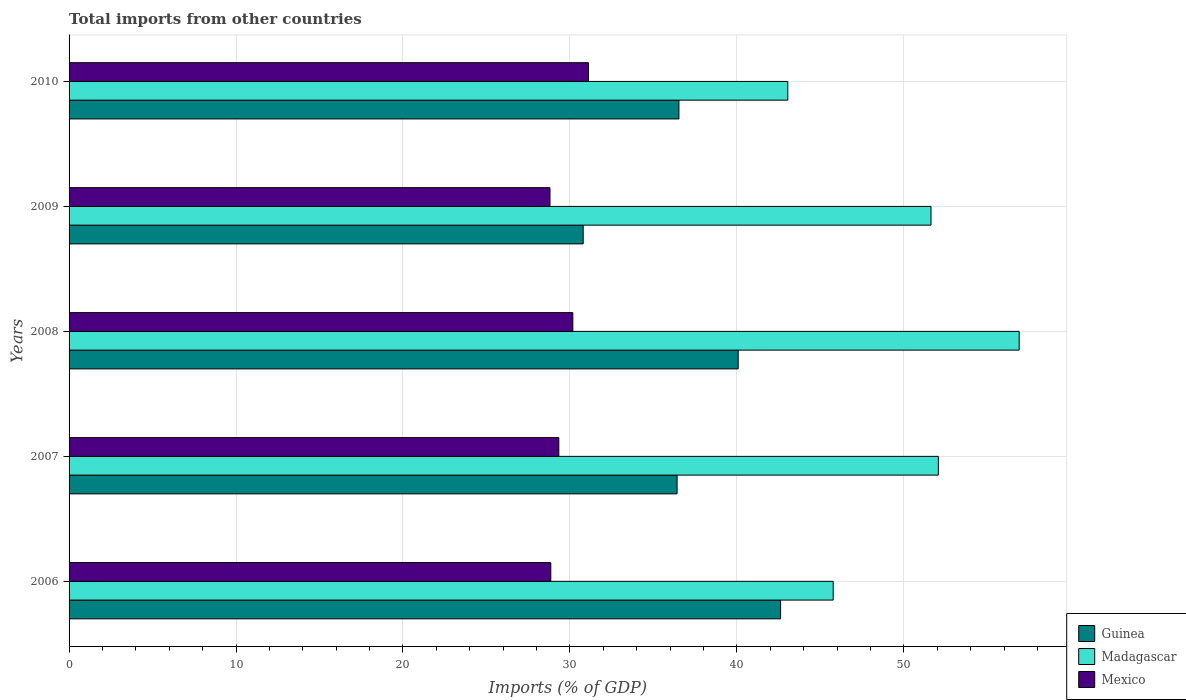How many groups of bars are there?
Ensure brevity in your answer.  5. How many bars are there on the 4th tick from the top?
Offer a terse response. 3. How many bars are there on the 4th tick from the bottom?
Provide a succinct answer. 3. What is the label of the 5th group of bars from the top?
Your answer should be very brief. 2006. In how many cases, is the number of bars for a given year not equal to the number of legend labels?
Ensure brevity in your answer.  0. What is the total imports in Guinea in 2010?
Give a very brief answer. 36.53. Across all years, what is the maximum total imports in Madagascar?
Give a very brief answer. 56.91. Across all years, what is the minimum total imports in Guinea?
Keep it short and to the point. 30.79. In which year was the total imports in Guinea maximum?
Your answer should be compact. 2006. In which year was the total imports in Madagascar minimum?
Ensure brevity in your answer.  2010. What is the total total imports in Guinea in the graph?
Give a very brief answer. 186.43. What is the difference between the total imports in Mexico in 2006 and that in 2010?
Make the answer very short. -2.26. What is the difference between the total imports in Mexico in 2006 and the total imports in Madagascar in 2009?
Offer a very short reply. -22.77. What is the average total imports in Guinea per year?
Your response must be concise. 37.29. In the year 2010, what is the difference between the total imports in Guinea and total imports in Madagascar?
Ensure brevity in your answer.  -6.52. In how many years, is the total imports in Madagascar greater than 50 %?
Offer a very short reply. 3. What is the ratio of the total imports in Guinea in 2008 to that in 2010?
Your response must be concise. 1.1. What is the difference between the highest and the second highest total imports in Guinea?
Your answer should be very brief. 2.54. What is the difference between the highest and the lowest total imports in Guinea?
Provide a succinct answer. 11.82. In how many years, is the total imports in Mexico greater than the average total imports in Mexico taken over all years?
Offer a terse response. 2. What does the 3rd bar from the top in 2006 represents?
Provide a short and direct response. Guinea. What does the 1st bar from the bottom in 2007 represents?
Provide a succinct answer. Guinea. Is it the case that in every year, the sum of the total imports in Mexico and total imports in Madagascar is greater than the total imports in Guinea?
Keep it short and to the point. Yes. How many bars are there?
Give a very brief answer. 15. How many years are there in the graph?
Offer a terse response. 5. Are the values on the major ticks of X-axis written in scientific E-notation?
Offer a terse response. No. Where does the legend appear in the graph?
Keep it short and to the point. Bottom right. What is the title of the graph?
Your response must be concise. Total imports from other countries. What is the label or title of the X-axis?
Provide a succinct answer. Imports (% of GDP). What is the label or title of the Y-axis?
Provide a succinct answer. Years. What is the Imports (% of GDP) in Guinea in 2006?
Keep it short and to the point. 42.62. What is the Imports (% of GDP) of Madagascar in 2006?
Make the answer very short. 45.77. What is the Imports (% of GDP) of Mexico in 2006?
Make the answer very short. 28.85. What is the Imports (% of GDP) of Guinea in 2007?
Offer a very short reply. 36.42. What is the Imports (% of GDP) of Madagascar in 2007?
Keep it short and to the point. 52.07. What is the Imports (% of GDP) in Mexico in 2007?
Provide a short and direct response. 29.33. What is the Imports (% of GDP) of Guinea in 2008?
Keep it short and to the point. 40.08. What is the Imports (% of GDP) in Madagascar in 2008?
Offer a terse response. 56.91. What is the Imports (% of GDP) in Mexico in 2008?
Provide a succinct answer. 30.17. What is the Imports (% of GDP) of Guinea in 2009?
Ensure brevity in your answer.  30.79. What is the Imports (% of GDP) of Madagascar in 2009?
Keep it short and to the point. 51.63. What is the Imports (% of GDP) of Mexico in 2009?
Your response must be concise. 28.81. What is the Imports (% of GDP) of Guinea in 2010?
Keep it short and to the point. 36.53. What is the Imports (% of GDP) of Madagascar in 2010?
Give a very brief answer. 43.05. What is the Imports (% of GDP) in Mexico in 2010?
Provide a short and direct response. 31.11. Across all years, what is the maximum Imports (% of GDP) of Guinea?
Your answer should be compact. 42.62. Across all years, what is the maximum Imports (% of GDP) in Madagascar?
Ensure brevity in your answer.  56.91. Across all years, what is the maximum Imports (% of GDP) of Mexico?
Provide a succinct answer. 31.11. Across all years, what is the minimum Imports (% of GDP) in Guinea?
Provide a succinct answer. 30.79. Across all years, what is the minimum Imports (% of GDP) in Madagascar?
Provide a succinct answer. 43.05. Across all years, what is the minimum Imports (% of GDP) of Mexico?
Provide a succinct answer. 28.81. What is the total Imports (% of GDP) in Guinea in the graph?
Ensure brevity in your answer.  186.43. What is the total Imports (% of GDP) in Madagascar in the graph?
Your answer should be very brief. 249.42. What is the total Imports (% of GDP) in Mexico in the graph?
Give a very brief answer. 148.28. What is the difference between the Imports (% of GDP) of Guinea in 2006 and that in 2007?
Keep it short and to the point. 6.2. What is the difference between the Imports (% of GDP) of Madagascar in 2006 and that in 2007?
Your answer should be compact. -6.3. What is the difference between the Imports (% of GDP) of Mexico in 2006 and that in 2007?
Your response must be concise. -0.48. What is the difference between the Imports (% of GDP) in Guinea in 2006 and that in 2008?
Your answer should be very brief. 2.54. What is the difference between the Imports (% of GDP) of Madagascar in 2006 and that in 2008?
Offer a terse response. -11.14. What is the difference between the Imports (% of GDP) in Mexico in 2006 and that in 2008?
Ensure brevity in your answer.  -1.32. What is the difference between the Imports (% of GDP) of Guinea in 2006 and that in 2009?
Ensure brevity in your answer.  11.82. What is the difference between the Imports (% of GDP) in Madagascar in 2006 and that in 2009?
Provide a short and direct response. -5.86. What is the difference between the Imports (% of GDP) in Mexico in 2006 and that in 2009?
Your answer should be compact. 0.05. What is the difference between the Imports (% of GDP) in Guinea in 2006 and that in 2010?
Offer a very short reply. 6.09. What is the difference between the Imports (% of GDP) in Madagascar in 2006 and that in 2010?
Your answer should be compact. 2.72. What is the difference between the Imports (% of GDP) in Mexico in 2006 and that in 2010?
Offer a very short reply. -2.26. What is the difference between the Imports (% of GDP) of Guinea in 2007 and that in 2008?
Offer a very short reply. -3.66. What is the difference between the Imports (% of GDP) in Madagascar in 2007 and that in 2008?
Ensure brevity in your answer.  -4.84. What is the difference between the Imports (% of GDP) in Mexico in 2007 and that in 2008?
Offer a terse response. -0.84. What is the difference between the Imports (% of GDP) in Guinea in 2007 and that in 2009?
Keep it short and to the point. 5.63. What is the difference between the Imports (% of GDP) in Madagascar in 2007 and that in 2009?
Give a very brief answer. 0.44. What is the difference between the Imports (% of GDP) in Mexico in 2007 and that in 2009?
Your answer should be very brief. 0.53. What is the difference between the Imports (% of GDP) of Guinea in 2007 and that in 2010?
Offer a very short reply. -0.11. What is the difference between the Imports (% of GDP) in Madagascar in 2007 and that in 2010?
Give a very brief answer. 9.02. What is the difference between the Imports (% of GDP) in Mexico in 2007 and that in 2010?
Your answer should be very brief. -1.78. What is the difference between the Imports (% of GDP) in Guinea in 2008 and that in 2009?
Provide a succinct answer. 9.28. What is the difference between the Imports (% of GDP) of Madagascar in 2008 and that in 2009?
Provide a succinct answer. 5.28. What is the difference between the Imports (% of GDP) in Mexico in 2008 and that in 2009?
Offer a terse response. 1.37. What is the difference between the Imports (% of GDP) in Guinea in 2008 and that in 2010?
Keep it short and to the point. 3.55. What is the difference between the Imports (% of GDP) in Madagascar in 2008 and that in 2010?
Ensure brevity in your answer.  13.86. What is the difference between the Imports (% of GDP) in Mexico in 2008 and that in 2010?
Keep it short and to the point. -0.94. What is the difference between the Imports (% of GDP) in Guinea in 2009 and that in 2010?
Your response must be concise. -5.73. What is the difference between the Imports (% of GDP) in Madagascar in 2009 and that in 2010?
Your response must be concise. 8.58. What is the difference between the Imports (% of GDP) in Mexico in 2009 and that in 2010?
Offer a terse response. -2.31. What is the difference between the Imports (% of GDP) in Guinea in 2006 and the Imports (% of GDP) in Madagascar in 2007?
Offer a very short reply. -9.45. What is the difference between the Imports (% of GDP) in Guinea in 2006 and the Imports (% of GDP) in Mexico in 2007?
Your answer should be very brief. 13.28. What is the difference between the Imports (% of GDP) in Madagascar in 2006 and the Imports (% of GDP) in Mexico in 2007?
Your answer should be very brief. 16.43. What is the difference between the Imports (% of GDP) in Guinea in 2006 and the Imports (% of GDP) in Madagascar in 2008?
Your response must be concise. -14.29. What is the difference between the Imports (% of GDP) in Guinea in 2006 and the Imports (% of GDP) in Mexico in 2008?
Offer a terse response. 12.44. What is the difference between the Imports (% of GDP) in Madagascar in 2006 and the Imports (% of GDP) in Mexico in 2008?
Provide a short and direct response. 15.6. What is the difference between the Imports (% of GDP) in Guinea in 2006 and the Imports (% of GDP) in Madagascar in 2009?
Give a very brief answer. -9.01. What is the difference between the Imports (% of GDP) of Guinea in 2006 and the Imports (% of GDP) of Mexico in 2009?
Provide a succinct answer. 13.81. What is the difference between the Imports (% of GDP) of Madagascar in 2006 and the Imports (% of GDP) of Mexico in 2009?
Keep it short and to the point. 16.96. What is the difference between the Imports (% of GDP) in Guinea in 2006 and the Imports (% of GDP) in Madagascar in 2010?
Your answer should be compact. -0.43. What is the difference between the Imports (% of GDP) of Guinea in 2006 and the Imports (% of GDP) of Mexico in 2010?
Give a very brief answer. 11.51. What is the difference between the Imports (% of GDP) of Madagascar in 2006 and the Imports (% of GDP) of Mexico in 2010?
Provide a succinct answer. 14.66. What is the difference between the Imports (% of GDP) in Guinea in 2007 and the Imports (% of GDP) in Madagascar in 2008?
Keep it short and to the point. -20.49. What is the difference between the Imports (% of GDP) in Guinea in 2007 and the Imports (% of GDP) in Mexico in 2008?
Your answer should be compact. 6.25. What is the difference between the Imports (% of GDP) of Madagascar in 2007 and the Imports (% of GDP) of Mexico in 2008?
Your answer should be very brief. 21.89. What is the difference between the Imports (% of GDP) of Guinea in 2007 and the Imports (% of GDP) of Madagascar in 2009?
Offer a terse response. -15.21. What is the difference between the Imports (% of GDP) of Guinea in 2007 and the Imports (% of GDP) of Mexico in 2009?
Keep it short and to the point. 7.61. What is the difference between the Imports (% of GDP) of Madagascar in 2007 and the Imports (% of GDP) of Mexico in 2009?
Your answer should be compact. 23.26. What is the difference between the Imports (% of GDP) of Guinea in 2007 and the Imports (% of GDP) of Madagascar in 2010?
Give a very brief answer. -6.63. What is the difference between the Imports (% of GDP) of Guinea in 2007 and the Imports (% of GDP) of Mexico in 2010?
Your answer should be compact. 5.31. What is the difference between the Imports (% of GDP) in Madagascar in 2007 and the Imports (% of GDP) in Mexico in 2010?
Make the answer very short. 20.96. What is the difference between the Imports (% of GDP) in Guinea in 2008 and the Imports (% of GDP) in Madagascar in 2009?
Give a very brief answer. -11.55. What is the difference between the Imports (% of GDP) of Guinea in 2008 and the Imports (% of GDP) of Mexico in 2009?
Provide a succinct answer. 11.27. What is the difference between the Imports (% of GDP) of Madagascar in 2008 and the Imports (% of GDP) of Mexico in 2009?
Your answer should be very brief. 28.1. What is the difference between the Imports (% of GDP) of Guinea in 2008 and the Imports (% of GDP) of Madagascar in 2010?
Provide a short and direct response. -2.97. What is the difference between the Imports (% of GDP) of Guinea in 2008 and the Imports (% of GDP) of Mexico in 2010?
Keep it short and to the point. 8.97. What is the difference between the Imports (% of GDP) of Madagascar in 2008 and the Imports (% of GDP) of Mexico in 2010?
Ensure brevity in your answer.  25.8. What is the difference between the Imports (% of GDP) in Guinea in 2009 and the Imports (% of GDP) in Madagascar in 2010?
Offer a terse response. -12.26. What is the difference between the Imports (% of GDP) in Guinea in 2009 and the Imports (% of GDP) in Mexico in 2010?
Provide a succinct answer. -0.32. What is the difference between the Imports (% of GDP) in Madagascar in 2009 and the Imports (% of GDP) in Mexico in 2010?
Your response must be concise. 20.52. What is the average Imports (% of GDP) of Guinea per year?
Provide a short and direct response. 37.29. What is the average Imports (% of GDP) in Madagascar per year?
Give a very brief answer. 49.88. What is the average Imports (% of GDP) in Mexico per year?
Your answer should be very brief. 29.66. In the year 2006, what is the difference between the Imports (% of GDP) of Guinea and Imports (% of GDP) of Madagascar?
Ensure brevity in your answer.  -3.15. In the year 2006, what is the difference between the Imports (% of GDP) in Guinea and Imports (% of GDP) in Mexico?
Offer a very short reply. 13.76. In the year 2006, what is the difference between the Imports (% of GDP) of Madagascar and Imports (% of GDP) of Mexico?
Offer a terse response. 16.91. In the year 2007, what is the difference between the Imports (% of GDP) in Guinea and Imports (% of GDP) in Madagascar?
Provide a succinct answer. -15.65. In the year 2007, what is the difference between the Imports (% of GDP) of Guinea and Imports (% of GDP) of Mexico?
Your answer should be compact. 7.08. In the year 2007, what is the difference between the Imports (% of GDP) in Madagascar and Imports (% of GDP) in Mexico?
Offer a terse response. 22.73. In the year 2008, what is the difference between the Imports (% of GDP) of Guinea and Imports (% of GDP) of Madagascar?
Give a very brief answer. -16.83. In the year 2008, what is the difference between the Imports (% of GDP) in Guinea and Imports (% of GDP) in Mexico?
Offer a terse response. 9.9. In the year 2008, what is the difference between the Imports (% of GDP) of Madagascar and Imports (% of GDP) of Mexico?
Your answer should be compact. 26.74. In the year 2009, what is the difference between the Imports (% of GDP) of Guinea and Imports (% of GDP) of Madagascar?
Provide a succinct answer. -20.83. In the year 2009, what is the difference between the Imports (% of GDP) in Guinea and Imports (% of GDP) in Mexico?
Offer a terse response. 1.99. In the year 2009, what is the difference between the Imports (% of GDP) of Madagascar and Imports (% of GDP) of Mexico?
Offer a very short reply. 22.82. In the year 2010, what is the difference between the Imports (% of GDP) in Guinea and Imports (% of GDP) in Madagascar?
Your response must be concise. -6.52. In the year 2010, what is the difference between the Imports (% of GDP) of Guinea and Imports (% of GDP) of Mexico?
Provide a succinct answer. 5.42. In the year 2010, what is the difference between the Imports (% of GDP) of Madagascar and Imports (% of GDP) of Mexico?
Offer a terse response. 11.94. What is the ratio of the Imports (% of GDP) of Guinea in 2006 to that in 2007?
Provide a succinct answer. 1.17. What is the ratio of the Imports (% of GDP) of Madagascar in 2006 to that in 2007?
Provide a short and direct response. 0.88. What is the ratio of the Imports (% of GDP) of Mexico in 2006 to that in 2007?
Offer a terse response. 0.98. What is the ratio of the Imports (% of GDP) of Guinea in 2006 to that in 2008?
Ensure brevity in your answer.  1.06. What is the ratio of the Imports (% of GDP) of Madagascar in 2006 to that in 2008?
Offer a very short reply. 0.8. What is the ratio of the Imports (% of GDP) in Mexico in 2006 to that in 2008?
Your response must be concise. 0.96. What is the ratio of the Imports (% of GDP) in Guinea in 2006 to that in 2009?
Keep it short and to the point. 1.38. What is the ratio of the Imports (% of GDP) in Madagascar in 2006 to that in 2009?
Offer a terse response. 0.89. What is the ratio of the Imports (% of GDP) of Mexico in 2006 to that in 2009?
Make the answer very short. 1. What is the ratio of the Imports (% of GDP) of Guinea in 2006 to that in 2010?
Your answer should be compact. 1.17. What is the ratio of the Imports (% of GDP) in Madagascar in 2006 to that in 2010?
Offer a very short reply. 1.06. What is the ratio of the Imports (% of GDP) in Mexico in 2006 to that in 2010?
Your response must be concise. 0.93. What is the ratio of the Imports (% of GDP) of Guinea in 2007 to that in 2008?
Your response must be concise. 0.91. What is the ratio of the Imports (% of GDP) in Madagascar in 2007 to that in 2008?
Ensure brevity in your answer.  0.91. What is the ratio of the Imports (% of GDP) in Mexico in 2007 to that in 2008?
Your answer should be very brief. 0.97. What is the ratio of the Imports (% of GDP) in Guinea in 2007 to that in 2009?
Your response must be concise. 1.18. What is the ratio of the Imports (% of GDP) of Madagascar in 2007 to that in 2009?
Offer a very short reply. 1.01. What is the ratio of the Imports (% of GDP) in Mexico in 2007 to that in 2009?
Your answer should be very brief. 1.02. What is the ratio of the Imports (% of GDP) of Madagascar in 2007 to that in 2010?
Make the answer very short. 1.21. What is the ratio of the Imports (% of GDP) of Mexico in 2007 to that in 2010?
Offer a terse response. 0.94. What is the ratio of the Imports (% of GDP) in Guinea in 2008 to that in 2009?
Offer a terse response. 1.3. What is the ratio of the Imports (% of GDP) of Madagascar in 2008 to that in 2009?
Your answer should be very brief. 1.1. What is the ratio of the Imports (% of GDP) in Mexico in 2008 to that in 2009?
Provide a succinct answer. 1.05. What is the ratio of the Imports (% of GDP) in Guinea in 2008 to that in 2010?
Provide a succinct answer. 1.1. What is the ratio of the Imports (% of GDP) in Madagascar in 2008 to that in 2010?
Make the answer very short. 1.32. What is the ratio of the Imports (% of GDP) in Mexico in 2008 to that in 2010?
Your response must be concise. 0.97. What is the ratio of the Imports (% of GDP) of Guinea in 2009 to that in 2010?
Provide a short and direct response. 0.84. What is the ratio of the Imports (% of GDP) in Madagascar in 2009 to that in 2010?
Make the answer very short. 1.2. What is the ratio of the Imports (% of GDP) of Mexico in 2009 to that in 2010?
Provide a succinct answer. 0.93. What is the difference between the highest and the second highest Imports (% of GDP) of Guinea?
Your response must be concise. 2.54. What is the difference between the highest and the second highest Imports (% of GDP) of Madagascar?
Provide a short and direct response. 4.84. What is the difference between the highest and the second highest Imports (% of GDP) of Mexico?
Your response must be concise. 0.94. What is the difference between the highest and the lowest Imports (% of GDP) in Guinea?
Provide a short and direct response. 11.82. What is the difference between the highest and the lowest Imports (% of GDP) in Madagascar?
Make the answer very short. 13.86. What is the difference between the highest and the lowest Imports (% of GDP) in Mexico?
Offer a very short reply. 2.31. 